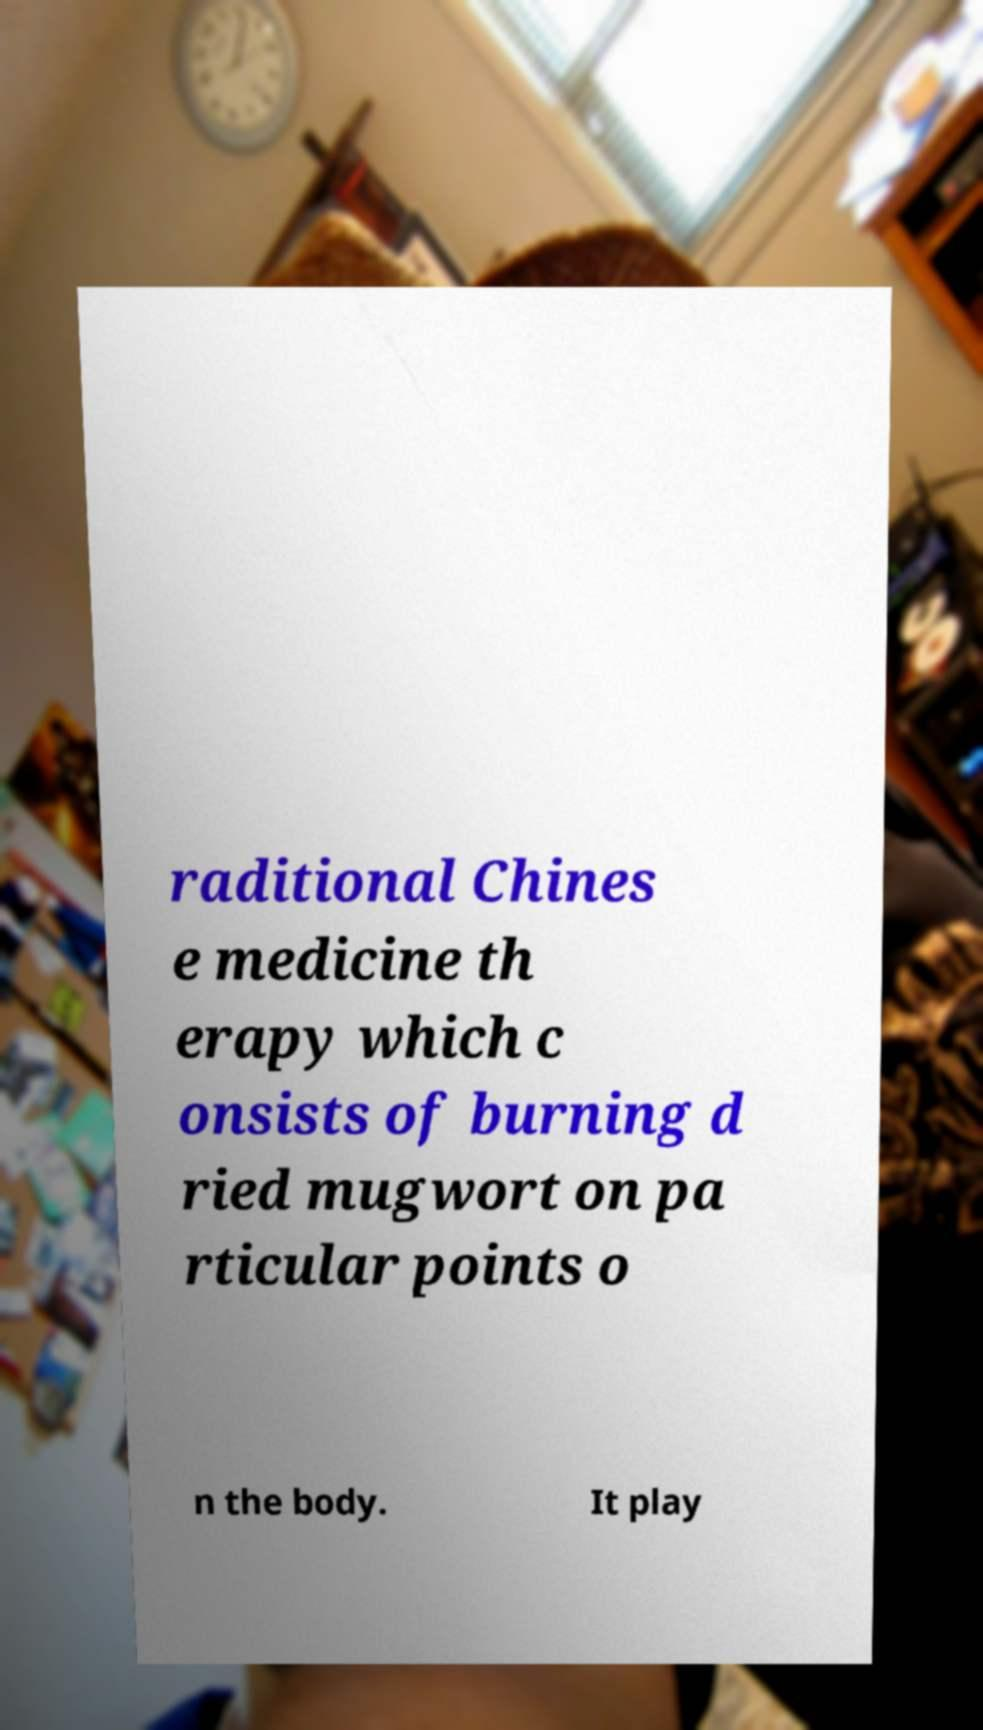Could you extract and type out the text from this image? raditional Chines e medicine th erapy which c onsists of burning d ried mugwort on pa rticular points o n the body. It play 